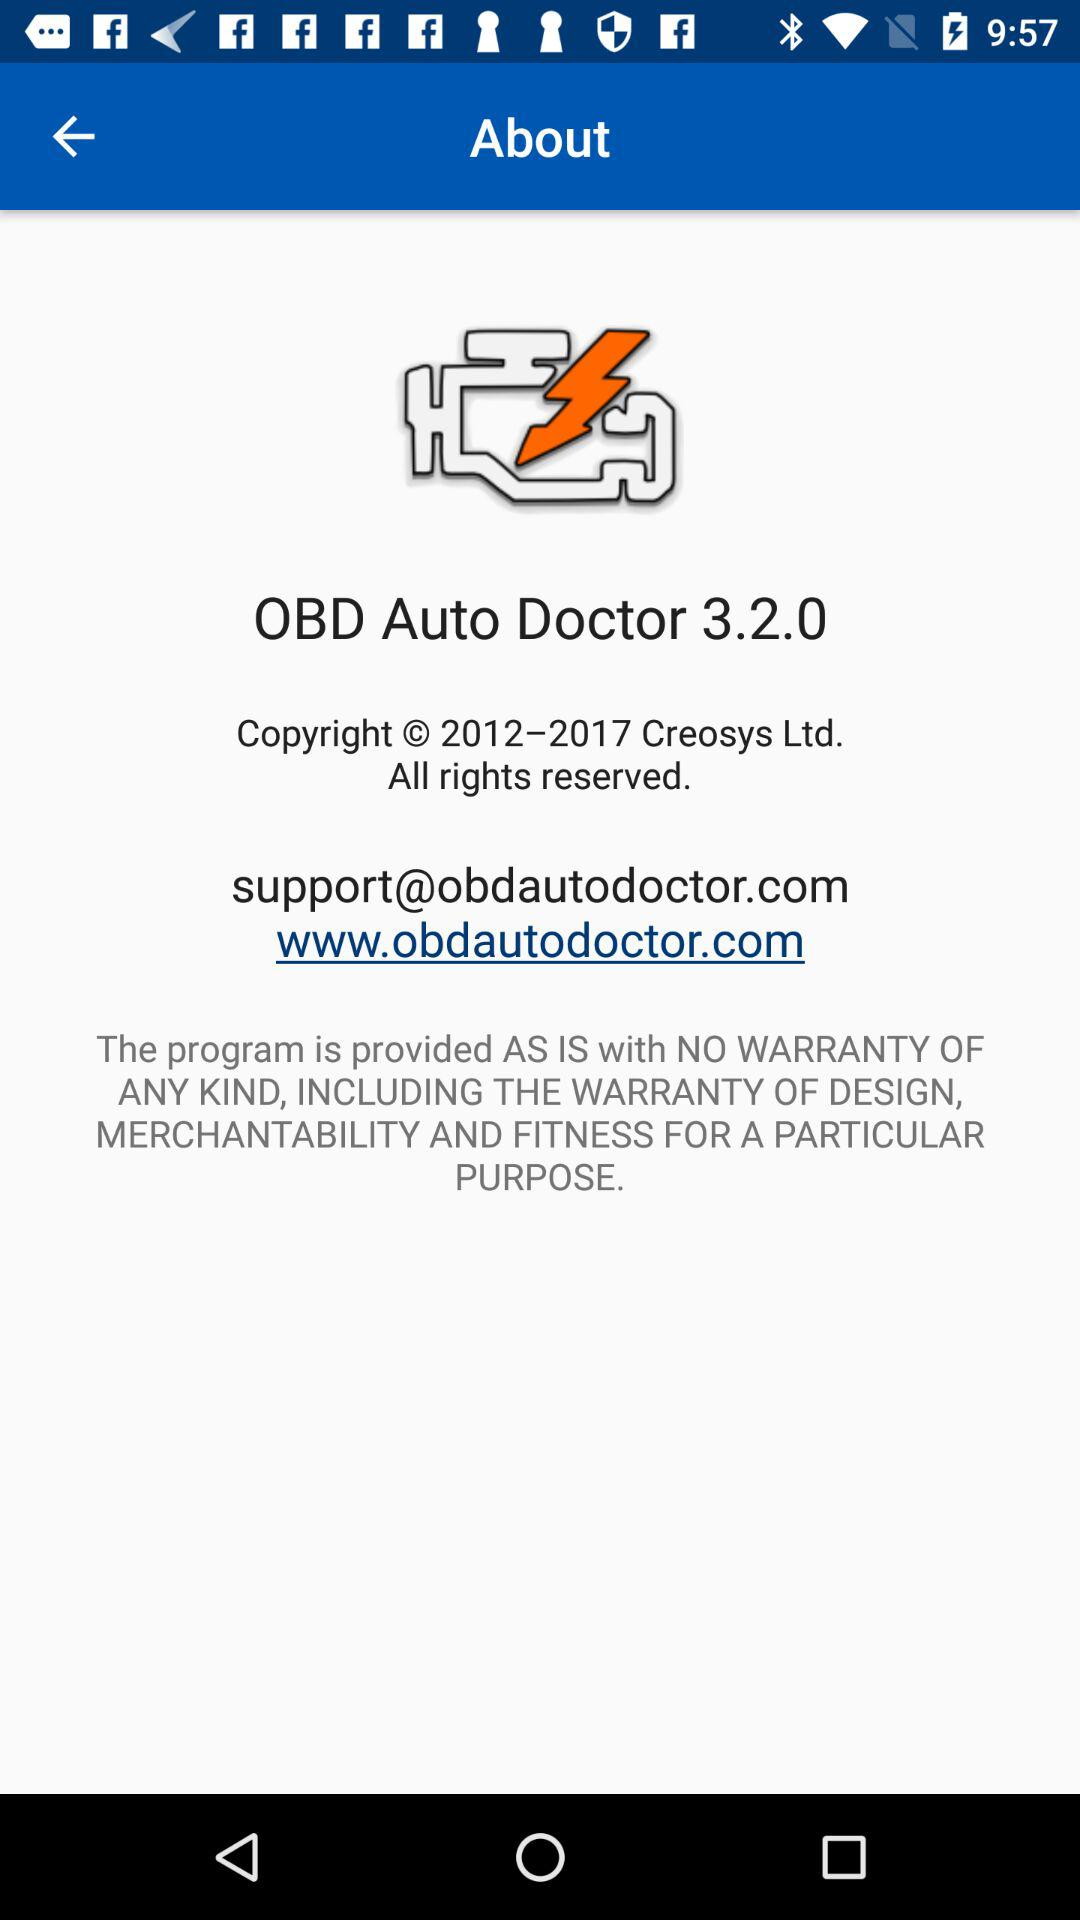What is the support email address? The support email address is support@obdautodoctor.com. 